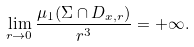Convert formula to latex. <formula><loc_0><loc_0><loc_500><loc_500>\lim _ { r \to 0 } \frac { \mu _ { 1 } ( \Sigma \cap D _ { x , r } ) } { r ^ { 3 } } = + \infty .</formula> 